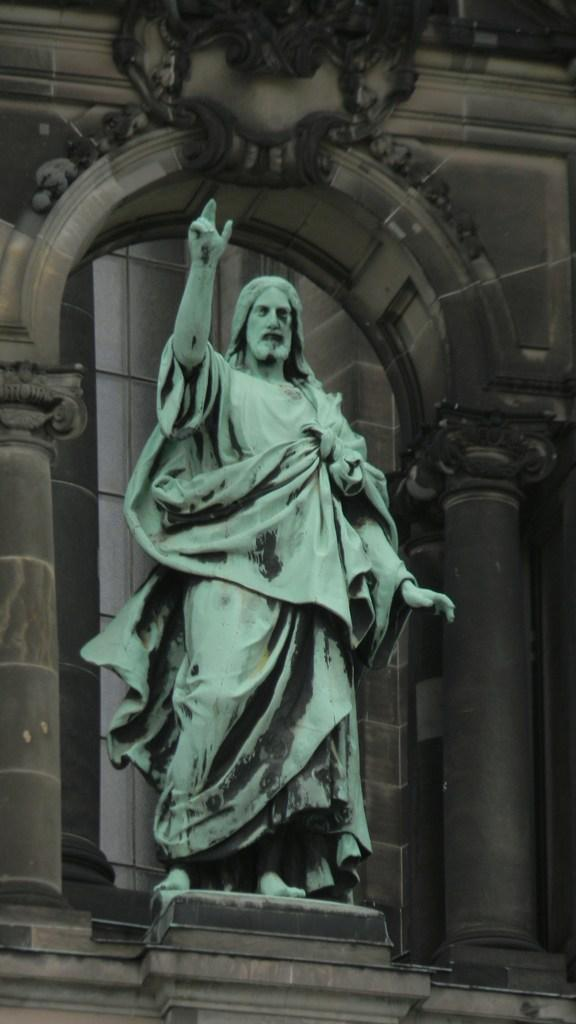What is the main subject in the image? There is a statue in the image. How is the statue positioned in the image? The statue is on a platform. What can be seen in the background of the image? There are pillars and a wall in the background of the image. Reasoning: Let'g: Let's think step by step in order to produce the conversation. We start by identifying the main subject in the image, which is the statue. Then, we describe the statue's positioning, noting that it is on a platform. Finally, we expand the conversation to include the background of the image, mentioning the presence of pillars and a wall. Absurd Question/Answer: What type of clover is the boy holding in the image? There is no boy or clover present in the image; it features a statue on a platform with pillars and a wall in the background. What is the taste of the statue in the image? The statue is not a consumable object, so it does not have a taste. 